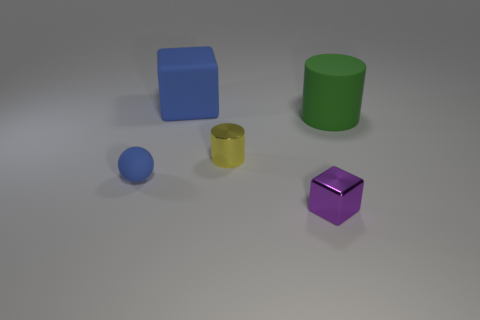Add 5 large blue rubber objects. How many objects exist? 10 Subtract all balls. How many objects are left? 4 Subtract 0 gray cylinders. How many objects are left? 5 Subtract all big blue blocks. Subtract all large things. How many objects are left? 2 Add 2 blocks. How many blocks are left? 4 Add 5 purple metal things. How many purple metal things exist? 6 